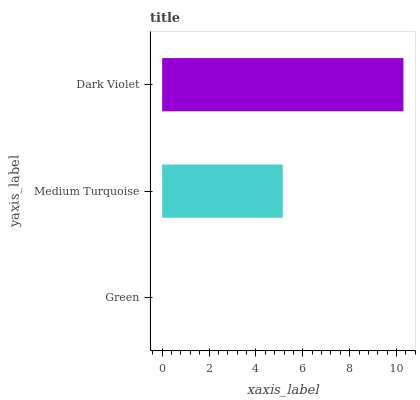Is Green the minimum?
Answer yes or no. Yes. Is Dark Violet the maximum?
Answer yes or no. Yes. Is Medium Turquoise the minimum?
Answer yes or no. No. Is Medium Turquoise the maximum?
Answer yes or no. No. Is Medium Turquoise greater than Green?
Answer yes or no. Yes. Is Green less than Medium Turquoise?
Answer yes or no. Yes. Is Green greater than Medium Turquoise?
Answer yes or no. No. Is Medium Turquoise less than Green?
Answer yes or no. No. Is Medium Turquoise the high median?
Answer yes or no. Yes. Is Medium Turquoise the low median?
Answer yes or no. Yes. Is Green the high median?
Answer yes or no. No. Is Dark Violet the low median?
Answer yes or no. No. 